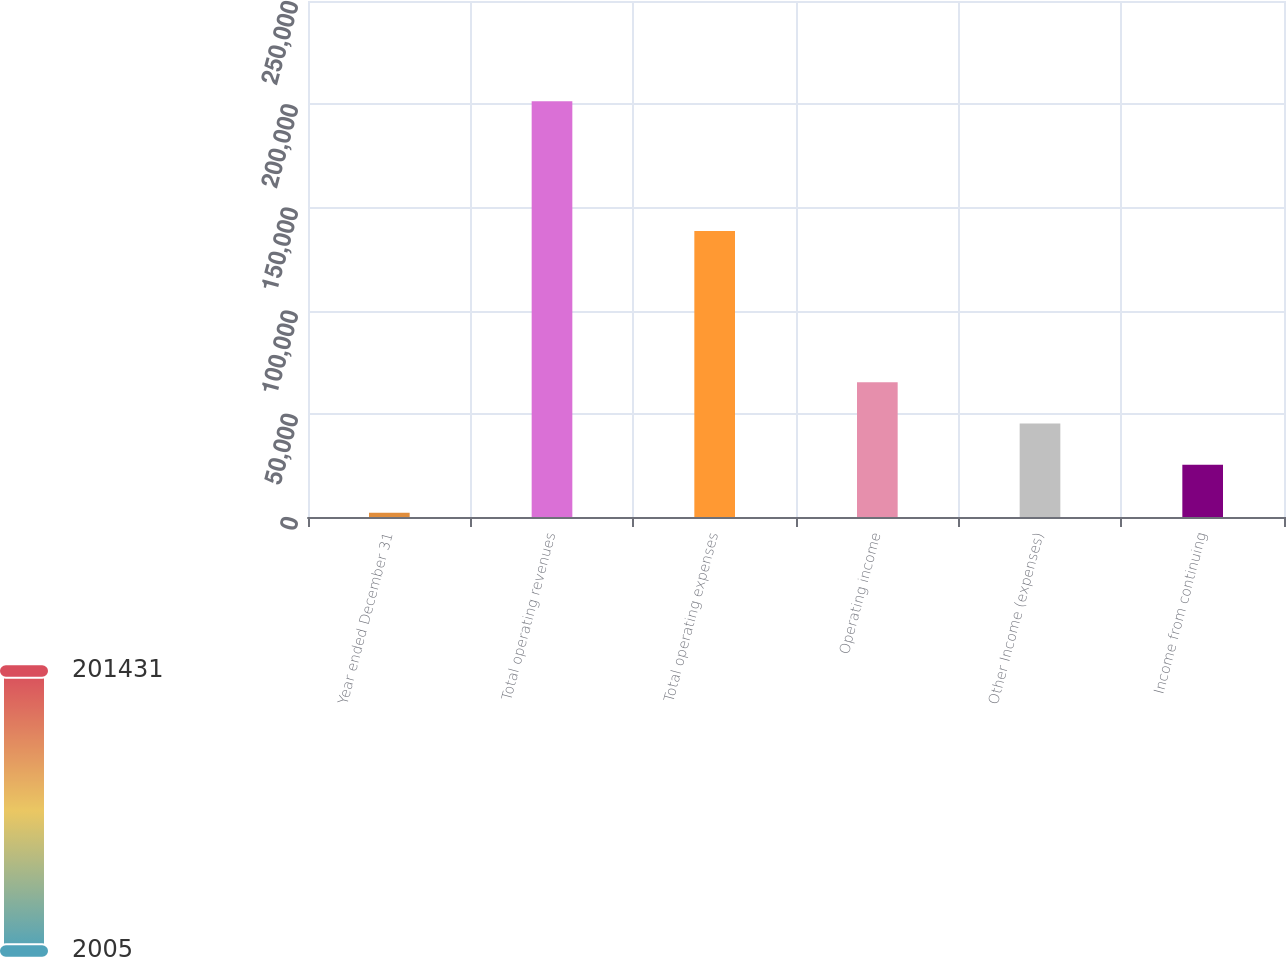Convert chart to OTSL. <chart><loc_0><loc_0><loc_500><loc_500><bar_chart><fcel>Year ended December 31<fcel>Total operating revenues<fcel>Total operating expenses<fcel>Operating income<fcel>Other Income (expenses)<fcel>Income from continuing<nl><fcel>2005<fcel>201431<fcel>138616<fcel>65229.2<fcel>45286.6<fcel>25344<nl></chart> 